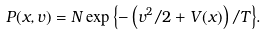<formula> <loc_0><loc_0><loc_500><loc_500>P ( x , v ) = N \exp { \left \{ - \left ( v ^ { 2 } / 2 + V ( x ) \right ) / T \right \} } .</formula> 